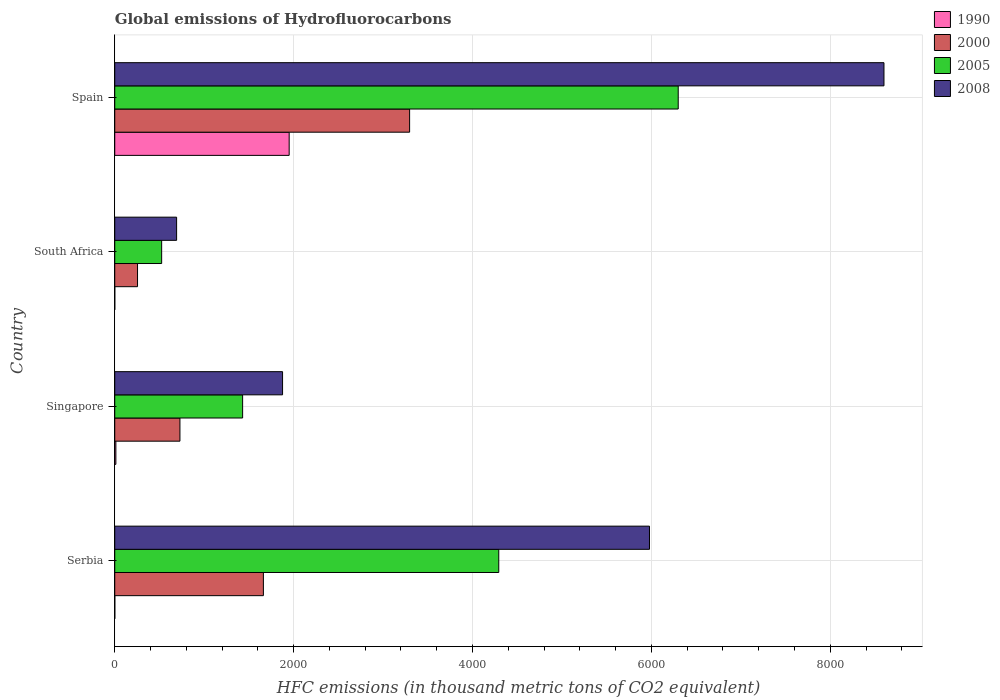How many groups of bars are there?
Your response must be concise. 4. Are the number of bars on each tick of the Y-axis equal?
Your answer should be compact. Yes. How many bars are there on the 4th tick from the bottom?
Provide a succinct answer. 4. What is the label of the 3rd group of bars from the top?
Offer a terse response. Singapore. What is the global emissions of Hydrofluorocarbons in 2000 in Spain?
Your response must be concise. 3296.8. Across all countries, what is the maximum global emissions of Hydrofluorocarbons in 2000?
Give a very brief answer. 3296.8. Across all countries, what is the minimum global emissions of Hydrofluorocarbons in 2000?
Offer a terse response. 254.6. In which country was the global emissions of Hydrofluorocarbons in 2000 maximum?
Your answer should be very brief. Spain. In which country was the global emissions of Hydrofluorocarbons in 2008 minimum?
Your answer should be very brief. South Africa. What is the total global emissions of Hydrofluorocarbons in 2000 in the graph?
Keep it short and to the point. 5942.3. What is the difference between the global emissions of Hydrofluorocarbons in 2008 in Serbia and that in South Africa?
Make the answer very short. 5287.4. What is the difference between the global emissions of Hydrofluorocarbons in 2000 in Singapore and the global emissions of Hydrofluorocarbons in 2005 in Spain?
Provide a short and direct response. -5571.4. What is the average global emissions of Hydrofluorocarbons in 2000 per country?
Provide a succinct answer. 1485.58. What is the difference between the global emissions of Hydrofluorocarbons in 2005 and global emissions of Hydrofluorocarbons in 2000 in Spain?
Provide a short and direct response. 3003.5. What is the ratio of the global emissions of Hydrofluorocarbons in 2008 in Serbia to that in South Africa?
Keep it short and to the point. 8.65. Is the global emissions of Hydrofluorocarbons in 2008 in South Africa less than that in Spain?
Give a very brief answer. Yes. What is the difference between the highest and the second highest global emissions of Hydrofluorocarbons in 2008?
Ensure brevity in your answer.  2621.9. What is the difference between the highest and the lowest global emissions of Hydrofluorocarbons in 2008?
Your response must be concise. 7909.3. Is it the case that in every country, the sum of the global emissions of Hydrofluorocarbons in 2000 and global emissions of Hydrofluorocarbons in 2005 is greater than the sum of global emissions of Hydrofluorocarbons in 1990 and global emissions of Hydrofluorocarbons in 2008?
Your answer should be compact. No. What does the 4th bar from the top in South Africa represents?
Offer a terse response. 1990. Is it the case that in every country, the sum of the global emissions of Hydrofluorocarbons in 2005 and global emissions of Hydrofluorocarbons in 1990 is greater than the global emissions of Hydrofluorocarbons in 2000?
Ensure brevity in your answer.  Yes. How many bars are there?
Your answer should be compact. 16. What is the difference between two consecutive major ticks on the X-axis?
Offer a terse response. 2000. Are the values on the major ticks of X-axis written in scientific E-notation?
Your response must be concise. No. Does the graph contain any zero values?
Keep it short and to the point. No. What is the title of the graph?
Ensure brevity in your answer.  Global emissions of Hydrofluorocarbons. Does "1962" appear as one of the legend labels in the graph?
Your response must be concise. No. What is the label or title of the X-axis?
Your response must be concise. HFC emissions (in thousand metric tons of CO2 equivalent). What is the HFC emissions (in thousand metric tons of CO2 equivalent) in 1990 in Serbia?
Your answer should be compact. 0.5. What is the HFC emissions (in thousand metric tons of CO2 equivalent) of 2000 in Serbia?
Provide a short and direct response. 1662. What is the HFC emissions (in thousand metric tons of CO2 equivalent) in 2005 in Serbia?
Give a very brief answer. 4293.8. What is the HFC emissions (in thousand metric tons of CO2 equivalent) in 2008 in Serbia?
Offer a terse response. 5979. What is the HFC emissions (in thousand metric tons of CO2 equivalent) in 1990 in Singapore?
Give a very brief answer. 12.6. What is the HFC emissions (in thousand metric tons of CO2 equivalent) of 2000 in Singapore?
Provide a succinct answer. 728.9. What is the HFC emissions (in thousand metric tons of CO2 equivalent) of 2005 in Singapore?
Your response must be concise. 1429.7. What is the HFC emissions (in thousand metric tons of CO2 equivalent) of 2008 in Singapore?
Offer a terse response. 1876.4. What is the HFC emissions (in thousand metric tons of CO2 equivalent) in 1990 in South Africa?
Give a very brief answer. 0.2. What is the HFC emissions (in thousand metric tons of CO2 equivalent) in 2000 in South Africa?
Offer a very short reply. 254.6. What is the HFC emissions (in thousand metric tons of CO2 equivalent) of 2005 in South Africa?
Your answer should be very brief. 524.5. What is the HFC emissions (in thousand metric tons of CO2 equivalent) of 2008 in South Africa?
Make the answer very short. 691.6. What is the HFC emissions (in thousand metric tons of CO2 equivalent) of 1990 in Spain?
Keep it short and to the point. 1950.3. What is the HFC emissions (in thousand metric tons of CO2 equivalent) in 2000 in Spain?
Provide a succinct answer. 3296.8. What is the HFC emissions (in thousand metric tons of CO2 equivalent) of 2005 in Spain?
Keep it short and to the point. 6300.3. What is the HFC emissions (in thousand metric tons of CO2 equivalent) of 2008 in Spain?
Offer a terse response. 8600.9. Across all countries, what is the maximum HFC emissions (in thousand metric tons of CO2 equivalent) in 1990?
Your answer should be very brief. 1950.3. Across all countries, what is the maximum HFC emissions (in thousand metric tons of CO2 equivalent) of 2000?
Ensure brevity in your answer.  3296.8. Across all countries, what is the maximum HFC emissions (in thousand metric tons of CO2 equivalent) of 2005?
Offer a terse response. 6300.3. Across all countries, what is the maximum HFC emissions (in thousand metric tons of CO2 equivalent) in 2008?
Make the answer very short. 8600.9. Across all countries, what is the minimum HFC emissions (in thousand metric tons of CO2 equivalent) in 1990?
Give a very brief answer. 0.2. Across all countries, what is the minimum HFC emissions (in thousand metric tons of CO2 equivalent) in 2000?
Your answer should be compact. 254.6. Across all countries, what is the minimum HFC emissions (in thousand metric tons of CO2 equivalent) of 2005?
Make the answer very short. 524.5. Across all countries, what is the minimum HFC emissions (in thousand metric tons of CO2 equivalent) of 2008?
Your response must be concise. 691.6. What is the total HFC emissions (in thousand metric tons of CO2 equivalent) in 1990 in the graph?
Your answer should be very brief. 1963.6. What is the total HFC emissions (in thousand metric tons of CO2 equivalent) of 2000 in the graph?
Ensure brevity in your answer.  5942.3. What is the total HFC emissions (in thousand metric tons of CO2 equivalent) of 2005 in the graph?
Keep it short and to the point. 1.25e+04. What is the total HFC emissions (in thousand metric tons of CO2 equivalent) in 2008 in the graph?
Ensure brevity in your answer.  1.71e+04. What is the difference between the HFC emissions (in thousand metric tons of CO2 equivalent) of 2000 in Serbia and that in Singapore?
Offer a terse response. 933.1. What is the difference between the HFC emissions (in thousand metric tons of CO2 equivalent) in 2005 in Serbia and that in Singapore?
Provide a short and direct response. 2864.1. What is the difference between the HFC emissions (in thousand metric tons of CO2 equivalent) of 2008 in Serbia and that in Singapore?
Your answer should be compact. 4102.6. What is the difference between the HFC emissions (in thousand metric tons of CO2 equivalent) in 1990 in Serbia and that in South Africa?
Provide a succinct answer. 0.3. What is the difference between the HFC emissions (in thousand metric tons of CO2 equivalent) of 2000 in Serbia and that in South Africa?
Provide a short and direct response. 1407.4. What is the difference between the HFC emissions (in thousand metric tons of CO2 equivalent) in 2005 in Serbia and that in South Africa?
Provide a succinct answer. 3769.3. What is the difference between the HFC emissions (in thousand metric tons of CO2 equivalent) of 2008 in Serbia and that in South Africa?
Make the answer very short. 5287.4. What is the difference between the HFC emissions (in thousand metric tons of CO2 equivalent) of 1990 in Serbia and that in Spain?
Provide a short and direct response. -1949.8. What is the difference between the HFC emissions (in thousand metric tons of CO2 equivalent) of 2000 in Serbia and that in Spain?
Provide a short and direct response. -1634.8. What is the difference between the HFC emissions (in thousand metric tons of CO2 equivalent) of 2005 in Serbia and that in Spain?
Your answer should be very brief. -2006.5. What is the difference between the HFC emissions (in thousand metric tons of CO2 equivalent) of 2008 in Serbia and that in Spain?
Your answer should be very brief. -2621.9. What is the difference between the HFC emissions (in thousand metric tons of CO2 equivalent) in 2000 in Singapore and that in South Africa?
Keep it short and to the point. 474.3. What is the difference between the HFC emissions (in thousand metric tons of CO2 equivalent) of 2005 in Singapore and that in South Africa?
Offer a very short reply. 905.2. What is the difference between the HFC emissions (in thousand metric tons of CO2 equivalent) of 2008 in Singapore and that in South Africa?
Provide a short and direct response. 1184.8. What is the difference between the HFC emissions (in thousand metric tons of CO2 equivalent) in 1990 in Singapore and that in Spain?
Provide a succinct answer. -1937.7. What is the difference between the HFC emissions (in thousand metric tons of CO2 equivalent) in 2000 in Singapore and that in Spain?
Keep it short and to the point. -2567.9. What is the difference between the HFC emissions (in thousand metric tons of CO2 equivalent) in 2005 in Singapore and that in Spain?
Give a very brief answer. -4870.6. What is the difference between the HFC emissions (in thousand metric tons of CO2 equivalent) of 2008 in Singapore and that in Spain?
Offer a terse response. -6724.5. What is the difference between the HFC emissions (in thousand metric tons of CO2 equivalent) in 1990 in South Africa and that in Spain?
Provide a short and direct response. -1950.1. What is the difference between the HFC emissions (in thousand metric tons of CO2 equivalent) in 2000 in South Africa and that in Spain?
Your answer should be very brief. -3042.2. What is the difference between the HFC emissions (in thousand metric tons of CO2 equivalent) in 2005 in South Africa and that in Spain?
Provide a short and direct response. -5775.8. What is the difference between the HFC emissions (in thousand metric tons of CO2 equivalent) of 2008 in South Africa and that in Spain?
Provide a succinct answer. -7909.3. What is the difference between the HFC emissions (in thousand metric tons of CO2 equivalent) of 1990 in Serbia and the HFC emissions (in thousand metric tons of CO2 equivalent) of 2000 in Singapore?
Provide a succinct answer. -728.4. What is the difference between the HFC emissions (in thousand metric tons of CO2 equivalent) in 1990 in Serbia and the HFC emissions (in thousand metric tons of CO2 equivalent) in 2005 in Singapore?
Provide a succinct answer. -1429.2. What is the difference between the HFC emissions (in thousand metric tons of CO2 equivalent) in 1990 in Serbia and the HFC emissions (in thousand metric tons of CO2 equivalent) in 2008 in Singapore?
Keep it short and to the point. -1875.9. What is the difference between the HFC emissions (in thousand metric tons of CO2 equivalent) in 2000 in Serbia and the HFC emissions (in thousand metric tons of CO2 equivalent) in 2005 in Singapore?
Make the answer very short. 232.3. What is the difference between the HFC emissions (in thousand metric tons of CO2 equivalent) of 2000 in Serbia and the HFC emissions (in thousand metric tons of CO2 equivalent) of 2008 in Singapore?
Offer a very short reply. -214.4. What is the difference between the HFC emissions (in thousand metric tons of CO2 equivalent) in 2005 in Serbia and the HFC emissions (in thousand metric tons of CO2 equivalent) in 2008 in Singapore?
Ensure brevity in your answer.  2417.4. What is the difference between the HFC emissions (in thousand metric tons of CO2 equivalent) of 1990 in Serbia and the HFC emissions (in thousand metric tons of CO2 equivalent) of 2000 in South Africa?
Offer a very short reply. -254.1. What is the difference between the HFC emissions (in thousand metric tons of CO2 equivalent) in 1990 in Serbia and the HFC emissions (in thousand metric tons of CO2 equivalent) in 2005 in South Africa?
Your response must be concise. -524. What is the difference between the HFC emissions (in thousand metric tons of CO2 equivalent) in 1990 in Serbia and the HFC emissions (in thousand metric tons of CO2 equivalent) in 2008 in South Africa?
Offer a terse response. -691.1. What is the difference between the HFC emissions (in thousand metric tons of CO2 equivalent) in 2000 in Serbia and the HFC emissions (in thousand metric tons of CO2 equivalent) in 2005 in South Africa?
Provide a succinct answer. 1137.5. What is the difference between the HFC emissions (in thousand metric tons of CO2 equivalent) in 2000 in Serbia and the HFC emissions (in thousand metric tons of CO2 equivalent) in 2008 in South Africa?
Make the answer very short. 970.4. What is the difference between the HFC emissions (in thousand metric tons of CO2 equivalent) in 2005 in Serbia and the HFC emissions (in thousand metric tons of CO2 equivalent) in 2008 in South Africa?
Your answer should be compact. 3602.2. What is the difference between the HFC emissions (in thousand metric tons of CO2 equivalent) of 1990 in Serbia and the HFC emissions (in thousand metric tons of CO2 equivalent) of 2000 in Spain?
Your response must be concise. -3296.3. What is the difference between the HFC emissions (in thousand metric tons of CO2 equivalent) of 1990 in Serbia and the HFC emissions (in thousand metric tons of CO2 equivalent) of 2005 in Spain?
Offer a very short reply. -6299.8. What is the difference between the HFC emissions (in thousand metric tons of CO2 equivalent) in 1990 in Serbia and the HFC emissions (in thousand metric tons of CO2 equivalent) in 2008 in Spain?
Your answer should be very brief. -8600.4. What is the difference between the HFC emissions (in thousand metric tons of CO2 equivalent) of 2000 in Serbia and the HFC emissions (in thousand metric tons of CO2 equivalent) of 2005 in Spain?
Offer a terse response. -4638.3. What is the difference between the HFC emissions (in thousand metric tons of CO2 equivalent) in 2000 in Serbia and the HFC emissions (in thousand metric tons of CO2 equivalent) in 2008 in Spain?
Your answer should be very brief. -6938.9. What is the difference between the HFC emissions (in thousand metric tons of CO2 equivalent) in 2005 in Serbia and the HFC emissions (in thousand metric tons of CO2 equivalent) in 2008 in Spain?
Provide a short and direct response. -4307.1. What is the difference between the HFC emissions (in thousand metric tons of CO2 equivalent) in 1990 in Singapore and the HFC emissions (in thousand metric tons of CO2 equivalent) in 2000 in South Africa?
Make the answer very short. -242. What is the difference between the HFC emissions (in thousand metric tons of CO2 equivalent) of 1990 in Singapore and the HFC emissions (in thousand metric tons of CO2 equivalent) of 2005 in South Africa?
Your response must be concise. -511.9. What is the difference between the HFC emissions (in thousand metric tons of CO2 equivalent) in 1990 in Singapore and the HFC emissions (in thousand metric tons of CO2 equivalent) in 2008 in South Africa?
Ensure brevity in your answer.  -679. What is the difference between the HFC emissions (in thousand metric tons of CO2 equivalent) in 2000 in Singapore and the HFC emissions (in thousand metric tons of CO2 equivalent) in 2005 in South Africa?
Provide a succinct answer. 204.4. What is the difference between the HFC emissions (in thousand metric tons of CO2 equivalent) in 2000 in Singapore and the HFC emissions (in thousand metric tons of CO2 equivalent) in 2008 in South Africa?
Make the answer very short. 37.3. What is the difference between the HFC emissions (in thousand metric tons of CO2 equivalent) of 2005 in Singapore and the HFC emissions (in thousand metric tons of CO2 equivalent) of 2008 in South Africa?
Provide a succinct answer. 738.1. What is the difference between the HFC emissions (in thousand metric tons of CO2 equivalent) of 1990 in Singapore and the HFC emissions (in thousand metric tons of CO2 equivalent) of 2000 in Spain?
Keep it short and to the point. -3284.2. What is the difference between the HFC emissions (in thousand metric tons of CO2 equivalent) of 1990 in Singapore and the HFC emissions (in thousand metric tons of CO2 equivalent) of 2005 in Spain?
Provide a short and direct response. -6287.7. What is the difference between the HFC emissions (in thousand metric tons of CO2 equivalent) of 1990 in Singapore and the HFC emissions (in thousand metric tons of CO2 equivalent) of 2008 in Spain?
Provide a short and direct response. -8588.3. What is the difference between the HFC emissions (in thousand metric tons of CO2 equivalent) of 2000 in Singapore and the HFC emissions (in thousand metric tons of CO2 equivalent) of 2005 in Spain?
Keep it short and to the point. -5571.4. What is the difference between the HFC emissions (in thousand metric tons of CO2 equivalent) in 2000 in Singapore and the HFC emissions (in thousand metric tons of CO2 equivalent) in 2008 in Spain?
Your response must be concise. -7872. What is the difference between the HFC emissions (in thousand metric tons of CO2 equivalent) of 2005 in Singapore and the HFC emissions (in thousand metric tons of CO2 equivalent) of 2008 in Spain?
Your answer should be compact. -7171.2. What is the difference between the HFC emissions (in thousand metric tons of CO2 equivalent) of 1990 in South Africa and the HFC emissions (in thousand metric tons of CO2 equivalent) of 2000 in Spain?
Your answer should be very brief. -3296.6. What is the difference between the HFC emissions (in thousand metric tons of CO2 equivalent) in 1990 in South Africa and the HFC emissions (in thousand metric tons of CO2 equivalent) in 2005 in Spain?
Your answer should be compact. -6300.1. What is the difference between the HFC emissions (in thousand metric tons of CO2 equivalent) in 1990 in South Africa and the HFC emissions (in thousand metric tons of CO2 equivalent) in 2008 in Spain?
Keep it short and to the point. -8600.7. What is the difference between the HFC emissions (in thousand metric tons of CO2 equivalent) in 2000 in South Africa and the HFC emissions (in thousand metric tons of CO2 equivalent) in 2005 in Spain?
Your answer should be compact. -6045.7. What is the difference between the HFC emissions (in thousand metric tons of CO2 equivalent) in 2000 in South Africa and the HFC emissions (in thousand metric tons of CO2 equivalent) in 2008 in Spain?
Ensure brevity in your answer.  -8346.3. What is the difference between the HFC emissions (in thousand metric tons of CO2 equivalent) of 2005 in South Africa and the HFC emissions (in thousand metric tons of CO2 equivalent) of 2008 in Spain?
Ensure brevity in your answer.  -8076.4. What is the average HFC emissions (in thousand metric tons of CO2 equivalent) of 1990 per country?
Your answer should be compact. 490.9. What is the average HFC emissions (in thousand metric tons of CO2 equivalent) of 2000 per country?
Offer a very short reply. 1485.58. What is the average HFC emissions (in thousand metric tons of CO2 equivalent) in 2005 per country?
Your answer should be compact. 3137.07. What is the average HFC emissions (in thousand metric tons of CO2 equivalent) of 2008 per country?
Provide a succinct answer. 4286.98. What is the difference between the HFC emissions (in thousand metric tons of CO2 equivalent) in 1990 and HFC emissions (in thousand metric tons of CO2 equivalent) in 2000 in Serbia?
Your answer should be compact. -1661.5. What is the difference between the HFC emissions (in thousand metric tons of CO2 equivalent) in 1990 and HFC emissions (in thousand metric tons of CO2 equivalent) in 2005 in Serbia?
Make the answer very short. -4293.3. What is the difference between the HFC emissions (in thousand metric tons of CO2 equivalent) in 1990 and HFC emissions (in thousand metric tons of CO2 equivalent) in 2008 in Serbia?
Offer a very short reply. -5978.5. What is the difference between the HFC emissions (in thousand metric tons of CO2 equivalent) in 2000 and HFC emissions (in thousand metric tons of CO2 equivalent) in 2005 in Serbia?
Ensure brevity in your answer.  -2631.8. What is the difference between the HFC emissions (in thousand metric tons of CO2 equivalent) of 2000 and HFC emissions (in thousand metric tons of CO2 equivalent) of 2008 in Serbia?
Ensure brevity in your answer.  -4317. What is the difference between the HFC emissions (in thousand metric tons of CO2 equivalent) of 2005 and HFC emissions (in thousand metric tons of CO2 equivalent) of 2008 in Serbia?
Provide a short and direct response. -1685.2. What is the difference between the HFC emissions (in thousand metric tons of CO2 equivalent) of 1990 and HFC emissions (in thousand metric tons of CO2 equivalent) of 2000 in Singapore?
Make the answer very short. -716.3. What is the difference between the HFC emissions (in thousand metric tons of CO2 equivalent) in 1990 and HFC emissions (in thousand metric tons of CO2 equivalent) in 2005 in Singapore?
Ensure brevity in your answer.  -1417.1. What is the difference between the HFC emissions (in thousand metric tons of CO2 equivalent) of 1990 and HFC emissions (in thousand metric tons of CO2 equivalent) of 2008 in Singapore?
Keep it short and to the point. -1863.8. What is the difference between the HFC emissions (in thousand metric tons of CO2 equivalent) of 2000 and HFC emissions (in thousand metric tons of CO2 equivalent) of 2005 in Singapore?
Provide a succinct answer. -700.8. What is the difference between the HFC emissions (in thousand metric tons of CO2 equivalent) of 2000 and HFC emissions (in thousand metric tons of CO2 equivalent) of 2008 in Singapore?
Ensure brevity in your answer.  -1147.5. What is the difference between the HFC emissions (in thousand metric tons of CO2 equivalent) in 2005 and HFC emissions (in thousand metric tons of CO2 equivalent) in 2008 in Singapore?
Your response must be concise. -446.7. What is the difference between the HFC emissions (in thousand metric tons of CO2 equivalent) of 1990 and HFC emissions (in thousand metric tons of CO2 equivalent) of 2000 in South Africa?
Make the answer very short. -254.4. What is the difference between the HFC emissions (in thousand metric tons of CO2 equivalent) of 1990 and HFC emissions (in thousand metric tons of CO2 equivalent) of 2005 in South Africa?
Ensure brevity in your answer.  -524.3. What is the difference between the HFC emissions (in thousand metric tons of CO2 equivalent) in 1990 and HFC emissions (in thousand metric tons of CO2 equivalent) in 2008 in South Africa?
Offer a very short reply. -691.4. What is the difference between the HFC emissions (in thousand metric tons of CO2 equivalent) of 2000 and HFC emissions (in thousand metric tons of CO2 equivalent) of 2005 in South Africa?
Make the answer very short. -269.9. What is the difference between the HFC emissions (in thousand metric tons of CO2 equivalent) in 2000 and HFC emissions (in thousand metric tons of CO2 equivalent) in 2008 in South Africa?
Provide a short and direct response. -437. What is the difference between the HFC emissions (in thousand metric tons of CO2 equivalent) of 2005 and HFC emissions (in thousand metric tons of CO2 equivalent) of 2008 in South Africa?
Make the answer very short. -167.1. What is the difference between the HFC emissions (in thousand metric tons of CO2 equivalent) in 1990 and HFC emissions (in thousand metric tons of CO2 equivalent) in 2000 in Spain?
Make the answer very short. -1346.5. What is the difference between the HFC emissions (in thousand metric tons of CO2 equivalent) in 1990 and HFC emissions (in thousand metric tons of CO2 equivalent) in 2005 in Spain?
Keep it short and to the point. -4350. What is the difference between the HFC emissions (in thousand metric tons of CO2 equivalent) in 1990 and HFC emissions (in thousand metric tons of CO2 equivalent) in 2008 in Spain?
Make the answer very short. -6650.6. What is the difference between the HFC emissions (in thousand metric tons of CO2 equivalent) of 2000 and HFC emissions (in thousand metric tons of CO2 equivalent) of 2005 in Spain?
Your response must be concise. -3003.5. What is the difference between the HFC emissions (in thousand metric tons of CO2 equivalent) of 2000 and HFC emissions (in thousand metric tons of CO2 equivalent) of 2008 in Spain?
Keep it short and to the point. -5304.1. What is the difference between the HFC emissions (in thousand metric tons of CO2 equivalent) of 2005 and HFC emissions (in thousand metric tons of CO2 equivalent) of 2008 in Spain?
Give a very brief answer. -2300.6. What is the ratio of the HFC emissions (in thousand metric tons of CO2 equivalent) in 1990 in Serbia to that in Singapore?
Provide a short and direct response. 0.04. What is the ratio of the HFC emissions (in thousand metric tons of CO2 equivalent) in 2000 in Serbia to that in Singapore?
Your answer should be compact. 2.28. What is the ratio of the HFC emissions (in thousand metric tons of CO2 equivalent) in 2005 in Serbia to that in Singapore?
Your answer should be compact. 3. What is the ratio of the HFC emissions (in thousand metric tons of CO2 equivalent) in 2008 in Serbia to that in Singapore?
Ensure brevity in your answer.  3.19. What is the ratio of the HFC emissions (in thousand metric tons of CO2 equivalent) of 2000 in Serbia to that in South Africa?
Your answer should be compact. 6.53. What is the ratio of the HFC emissions (in thousand metric tons of CO2 equivalent) in 2005 in Serbia to that in South Africa?
Keep it short and to the point. 8.19. What is the ratio of the HFC emissions (in thousand metric tons of CO2 equivalent) of 2008 in Serbia to that in South Africa?
Offer a terse response. 8.65. What is the ratio of the HFC emissions (in thousand metric tons of CO2 equivalent) in 1990 in Serbia to that in Spain?
Your answer should be very brief. 0. What is the ratio of the HFC emissions (in thousand metric tons of CO2 equivalent) in 2000 in Serbia to that in Spain?
Offer a terse response. 0.5. What is the ratio of the HFC emissions (in thousand metric tons of CO2 equivalent) of 2005 in Serbia to that in Spain?
Give a very brief answer. 0.68. What is the ratio of the HFC emissions (in thousand metric tons of CO2 equivalent) in 2008 in Serbia to that in Spain?
Make the answer very short. 0.7. What is the ratio of the HFC emissions (in thousand metric tons of CO2 equivalent) in 2000 in Singapore to that in South Africa?
Your response must be concise. 2.86. What is the ratio of the HFC emissions (in thousand metric tons of CO2 equivalent) in 2005 in Singapore to that in South Africa?
Your answer should be very brief. 2.73. What is the ratio of the HFC emissions (in thousand metric tons of CO2 equivalent) of 2008 in Singapore to that in South Africa?
Keep it short and to the point. 2.71. What is the ratio of the HFC emissions (in thousand metric tons of CO2 equivalent) in 1990 in Singapore to that in Spain?
Your response must be concise. 0.01. What is the ratio of the HFC emissions (in thousand metric tons of CO2 equivalent) of 2000 in Singapore to that in Spain?
Give a very brief answer. 0.22. What is the ratio of the HFC emissions (in thousand metric tons of CO2 equivalent) of 2005 in Singapore to that in Spain?
Keep it short and to the point. 0.23. What is the ratio of the HFC emissions (in thousand metric tons of CO2 equivalent) in 2008 in Singapore to that in Spain?
Provide a short and direct response. 0.22. What is the ratio of the HFC emissions (in thousand metric tons of CO2 equivalent) in 2000 in South Africa to that in Spain?
Offer a terse response. 0.08. What is the ratio of the HFC emissions (in thousand metric tons of CO2 equivalent) in 2005 in South Africa to that in Spain?
Offer a very short reply. 0.08. What is the ratio of the HFC emissions (in thousand metric tons of CO2 equivalent) in 2008 in South Africa to that in Spain?
Make the answer very short. 0.08. What is the difference between the highest and the second highest HFC emissions (in thousand metric tons of CO2 equivalent) of 1990?
Offer a very short reply. 1937.7. What is the difference between the highest and the second highest HFC emissions (in thousand metric tons of CO2 equivalent) of 2000?
Make the answer very short. 1634.8. What is the difference between the highest and the second highest HFC emissions (in thousand metric tons of CO2 equivalent) of 2005?
Your response must be concise. 2006.5. What is the difference between the highest and the second highest HFC emissions (in thousand metric tons of CO2 equivalent) of 2008?
Your answer should be compact. 2621.9. What is the difference between the highest and the lowest HFC emissions (in thousand metric tons of CO2 equivalent) of 1990?
Offer a very short reply. 1950.1. What is the difference between the highest and the lowest HFC emissions (in thousand metric tons of CO2 equivalent) of 2000?
Your answer should be compact. 3042.2. What is the difference between the highest and the lowest HFC emissions (in thousand metric tons of CO2 equivalent) of 2005?
Your answer should be very brief. 5775.8. What is the difference between the highest and the lowest HFC emissions (in thousand metric tons of CO2 equivalent) of 2008?
Your answer should be very brief. 7909.3. 